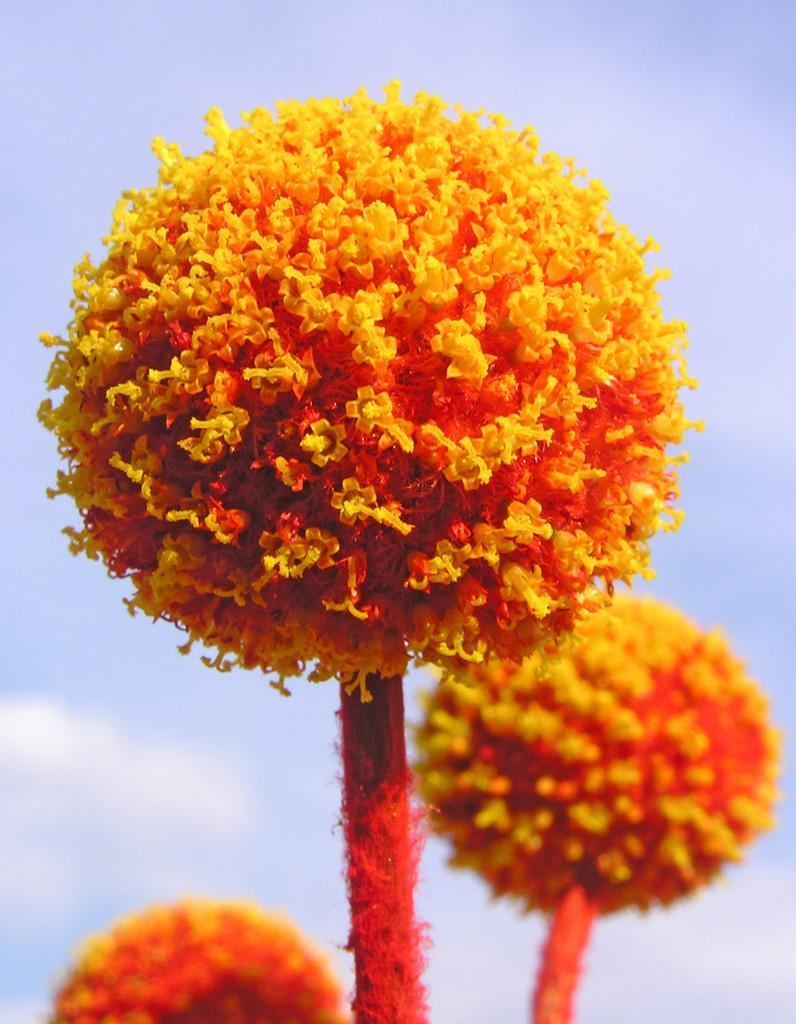How many flowers are present in the image? There are 3 flowers in the image. What colors can be seen on the flowers? The flowers are orange and red in color. What can be seen in the background of the image? There is a sky visible in the background of the image. What type of leather is being used to hold the flowers in the image? There is no leather present in the image. The flowers are not being held by any leather. 